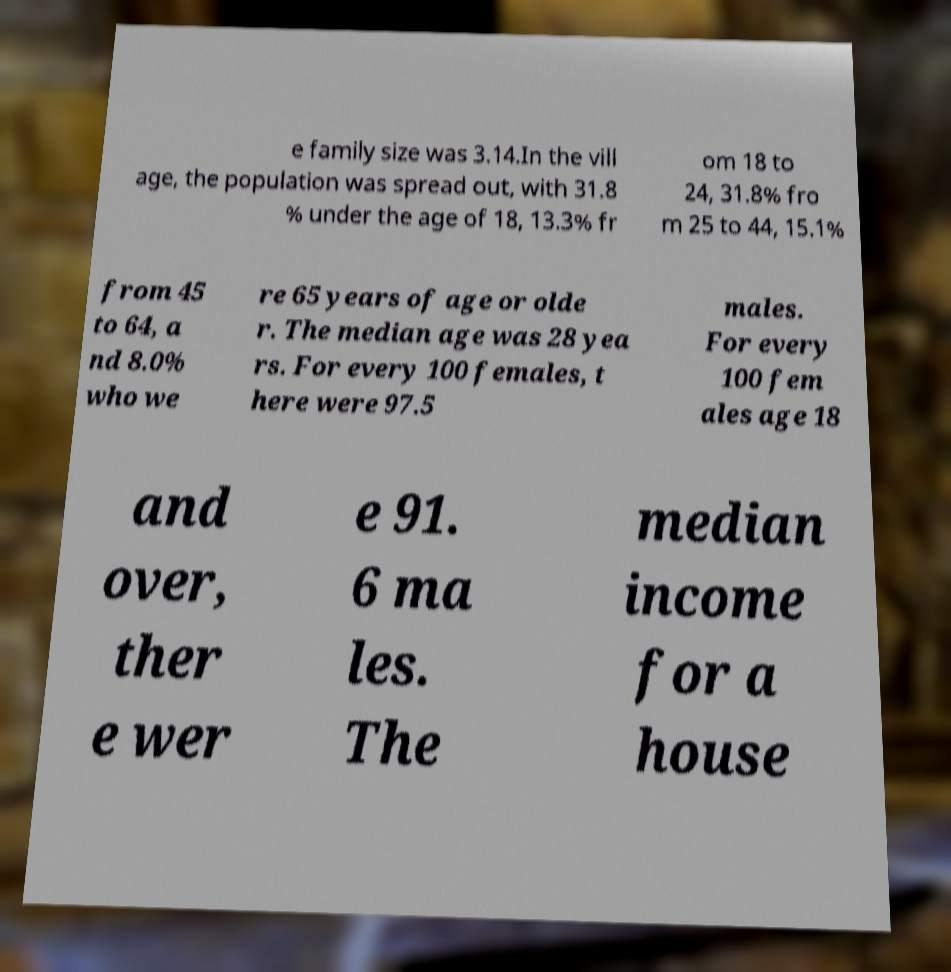Please read and relay the text visible in this image. What does it say? e family size was 3.14.In the vill age, the population was spread out, with 31.8 % under the age of 18, 13.3% fr om 18 to 24, 31.8% fro m 25 to 44, 15.1% from 45 to 64, a nd 8.0% who we re 65 years of age or olde r. The median age was 28 yea rs. For every 100 females, t here were 97.5 males. For every 100 fem ales age 18 and over, ther e wer e 91. 6 ma les. The median income for a house 